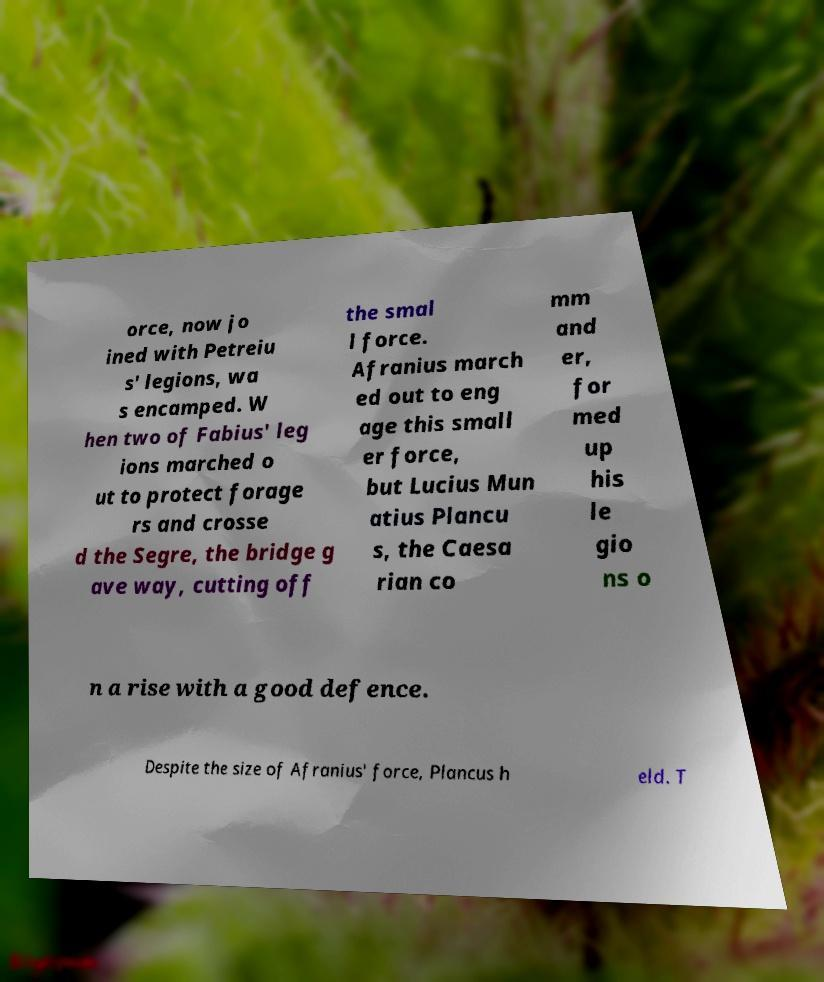For documentation purposes, I need the text within this image transcribed. Could you provide that? orce, now jo ined with Petreiu s' legions, wa s encamped. W hen two of Fabius' leg ions marched o ut to protect forage rs and crosse d the Segre, the bridge g ave way, cutting off the smal l force. Afranius march ed out to eng age this small er force, but Lucius Mun atius Plancu s, the Caesa rian co mm and er, for med up his le gio ns o n a rise with a good defence. Despite the size of Afranius' force, Plancus h eld. T 